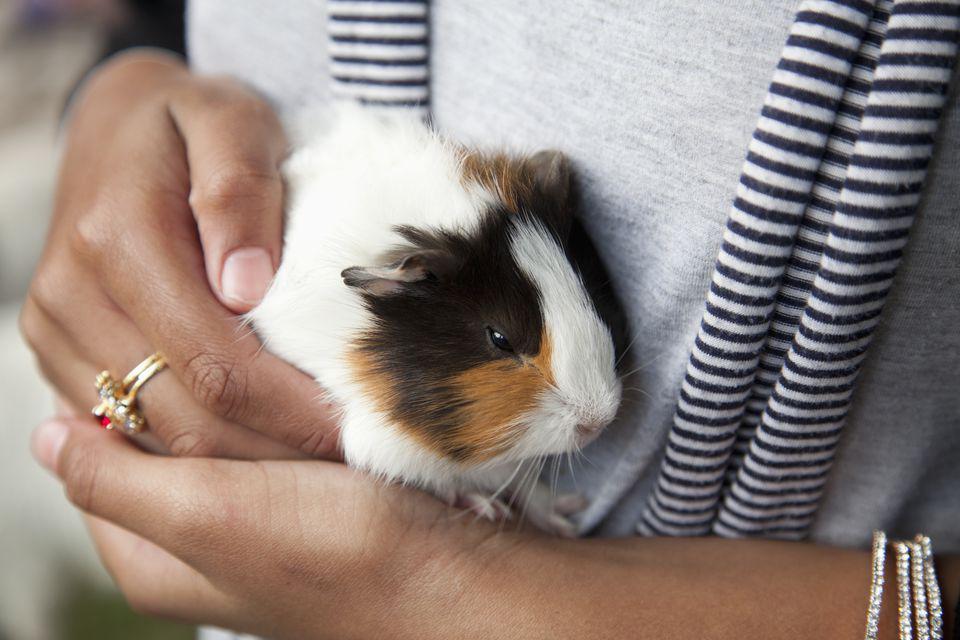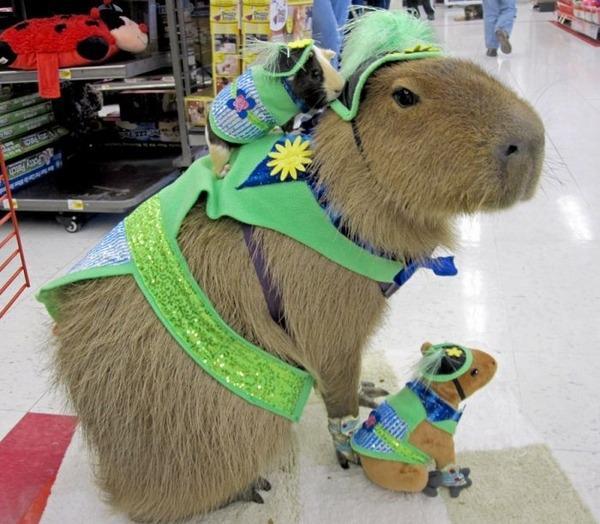The first image is the image on the left, the second image is the image on the right. Evaluate the accuracy of this statement regarding the images: "There is a guinea pig in the right image looking towards the right.". Is it true? Answer yes or no. Yes. The first image is the image on the left, the second image is the image on the right. Analyze the images presented: Is the assertion "Each image shows a guinea pigs held in an upturned palm of at least one hand." valid? Answer yes or no. No. 